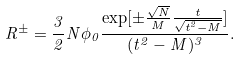Convert formula to latex. <formula><loc_0><loc_0><loc_500><loc_500>R ^ { \pm } = \frac { 3 } { 2 } N \phi _ { 0 } \frac { \exp [ \pm \frac { \sqrt { N } } { M } \frac { t } { \sqrt { t ^ { 2 } - M } } ] } { ( t ^ { 2 } - M ) ^ { 3 } } .</formula> 